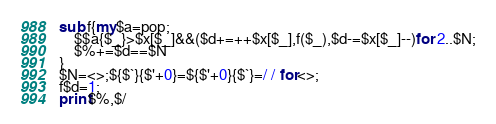<code> <loc_0><loc_0><loc_500><loc_500><_Perl_>sub f{my$a=pop;
	$$a{$_}>$x[$_]&&($d+=++$x[$_],f($_),$d-=$x[$_]--)for 2..$N;
	$%+=$d==$N
}
$N=<>;${$`}{$'+0}=${$'+0}{$`}=/ / for<>;
f$d=1;
print$%,$/
</code> 